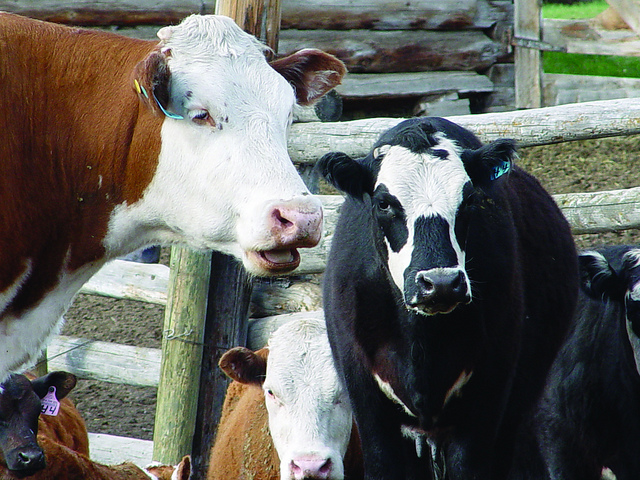Who put the tag on the cows ear?
A. alien
B. another cow
C. dog
D. human
Answer with the option's letter from the given choices directly. D 